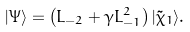<formula> <loc_0><loc_0><loc_500><loc_500>| \Psi \rangle = \left ( L _ { - 2 } + \gamma L _ { - 1 } ^ { 2 } \right ) | \tilde { \chi } _ { 1 } \rangle .</formula> 